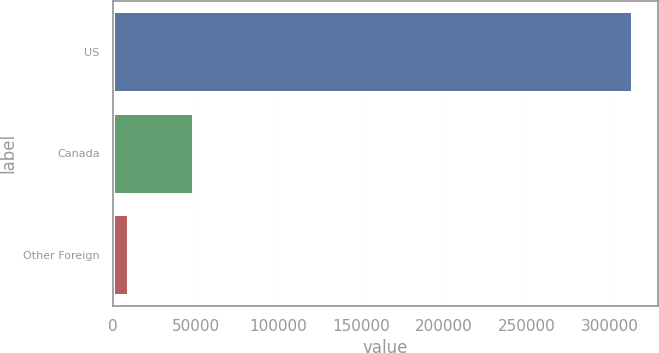Convert chart. <chart><loc_0><loc_0><loc_500><loc_500><bar_chart><fcel>US<fcel>Canada<fcel>Other Foreign<nl><fcel>313530<fcel>48327<fcel>8957<nl></chart> 